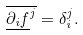<formula> <loc_0><loc_0><loc_500><loc_500>\overline { \underline { \partial _ { i } f } ^ { j } } = \delta _ { i } ^ { j } .</formula> 